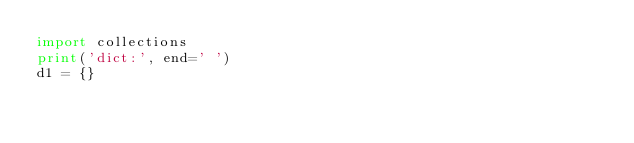<code> <loc_0><loc_0><loc_500><loc_500><_Python_>import collections
print('dict:', end=' ')
d1 = {}</code> 